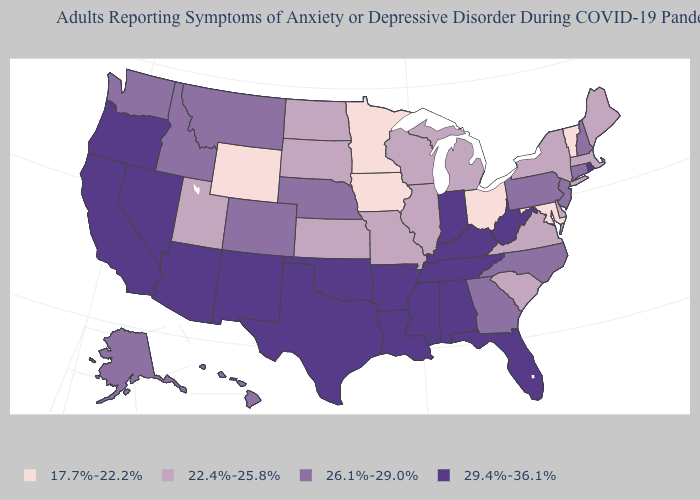Among the states that border Nevada , does Idaho have the lowest value?
Concise answer only. No. What is the highest value in the West ?
Keep it brief. 29.4%-36.1%. Is the legend a continuous bar?
Short answer required. No. Does the map have missing data?
Keep it brief. No. What is the value of Nevada?
Be succinct. 29.4%-36.1%. Among the states that border Alabama , does Georgia have the lowest value?
Answer briefly. Yes. Does the first symbol in the legend represent the smallest category?
Write a very short answer. Yes. What is the value of New York?
Be succinct. 22.4%-25.8%. What is the value of Iowa?
Short answer required. 17.7%-22.2%. Among the states that border South Dakota , which have the lowest value?
Answer briefly. Iowa, Minnesota, Wyoming. What is the highest value in the West ?
Short answer required. 29.4%-36.1%. What is the lowest value in the MidWest?
Give a very brief answer. 17.7%-22.2%. Does Mississippi have the same value as New Mexico?
Quick response, please. Yes. Does Ohio have the lowest value in the USA?
Keep it brief. Yes. What is the value of Missouri?
Keep it brief. 22.4%-25.8%. 